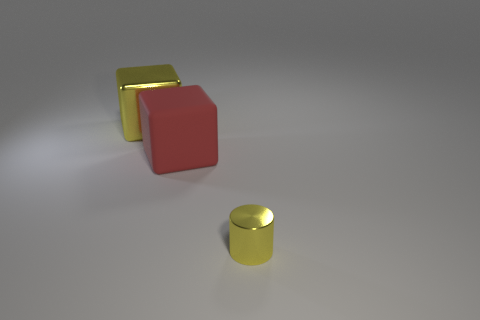Add 3 shiny spheres. How many objects exist? 6 Subtract all red blocks. How many blocks are left? 1 Subtract all cubes. How many objects are left? 1 Add 1 large shiny cubes. How many large shiny cubes exist? 2 Subtract 0 red cylinders. How many objects are left? 3 Subtract 2 cubes. How many cubes are left? 0 Subtract all purple cubes. Subtract all cyan spheres. How many cubes are left? 2 Subtract all yellow blocks. How many brown cylinders are left? 0 Subtract all large objects. Subtract all matte objects. How many objects are left? 0 Add 1 shiny cubes. How many shiny cubes are left? 2 